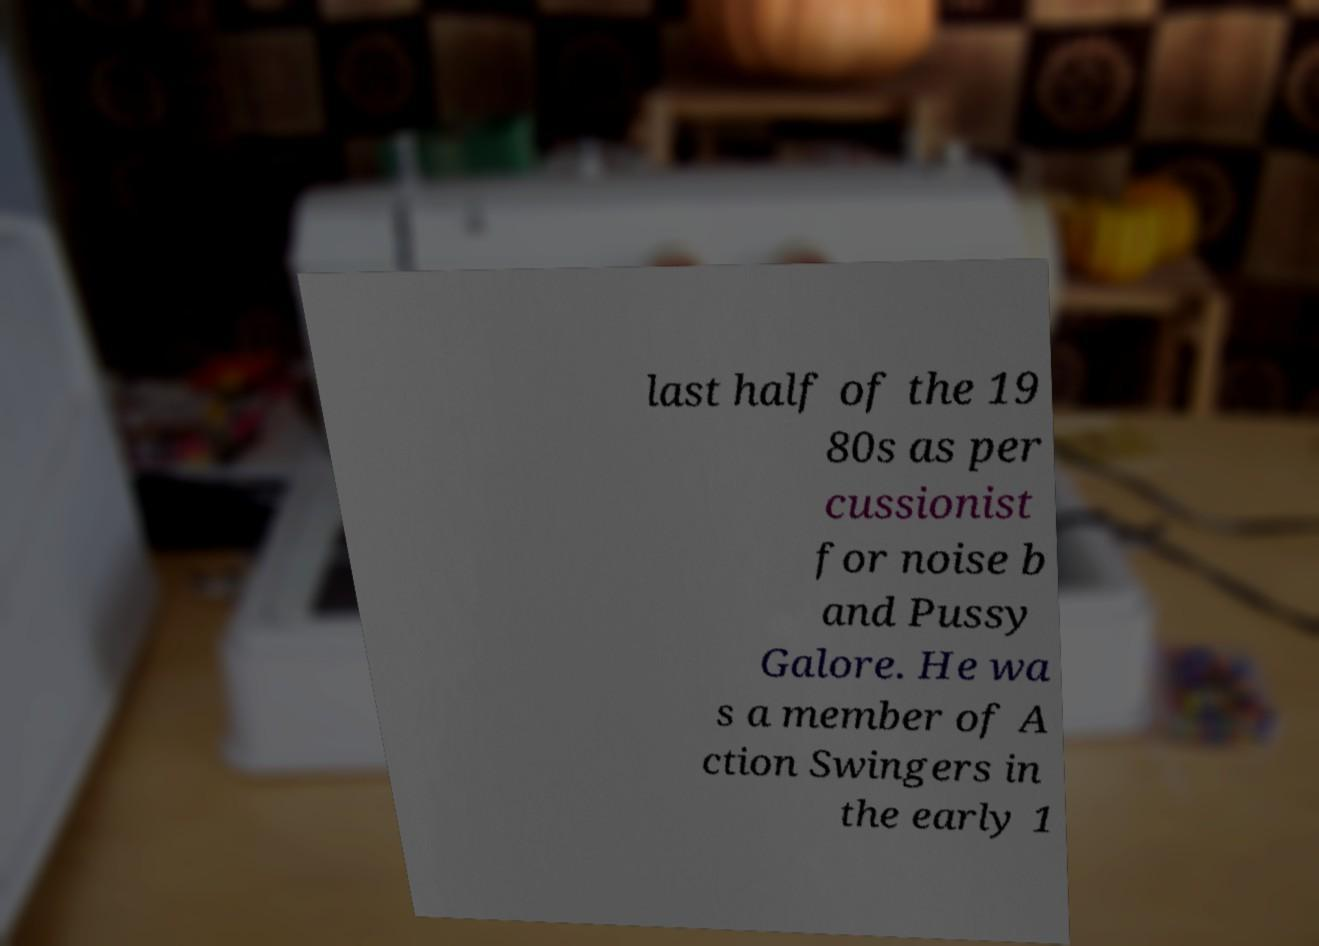Can you accurately transcribe the text from the provided image for me? last half of the 19 80s as per cussionist for noise b and Pussy Galore. He wa s a member of A ction Swingers in the early 1 